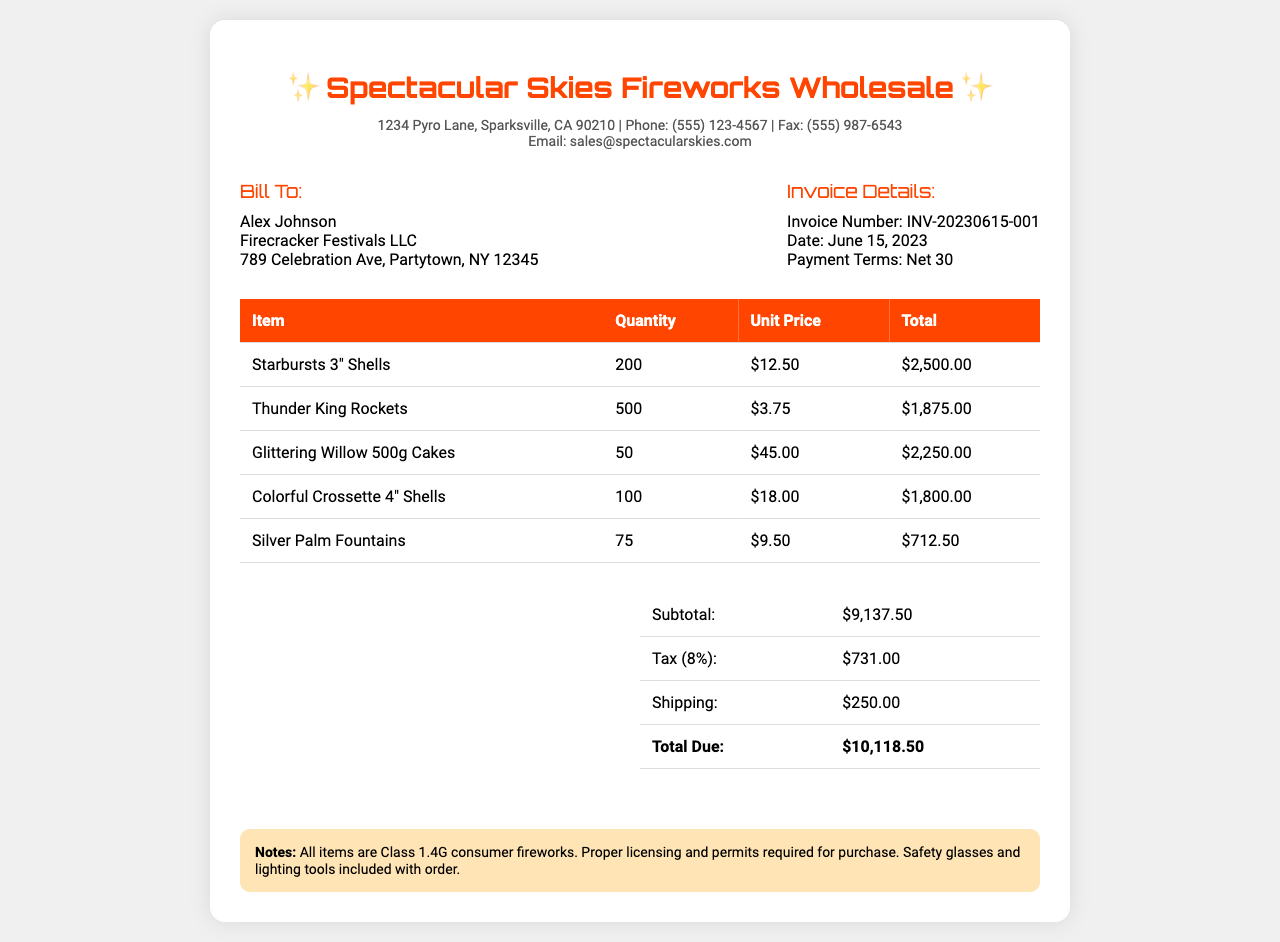What is the total due amount? The total due amount is detailed in the totals section of the document, which adds up the subtotal, tax, and shipping.
Answer: $10,118.50 Who is billed? The billing information consists of the name and company provided in the document, which identifies the recipient.
Answer: Alex Johnson When was the invoice issued? The issued date of the invoice is clearly stated in the invoice details section.
Answer: June 15, 2023 What is the payment term stated in the invoice? The payment terms are included to clarify when the payment is expected following receipt of the invoice.
Answer: Net 30 How many Thunder King Rockets were ordered? The quantity of Thunder King Rockets is specified in the detailed itemized list of the invoice.
Answer: 500 What is the subtotal of the invoice? The subtotal is explicitly shown in the totals table, summarizing the costs before tax and shipping.
Answer: $9,137.50 How much was charged for shipping? The shipping cost is provided in the totals section of the invoice, adding to the overall amount due.
Answer: $250.00 What item has the highest unit price? By reviewing the itemized list, we can identify which fireworks have the highest price per unit.
Answer: Glittering Willow 500g Cakes What percentage is the tax applied? The invoice details indicate the tax rate applied to the subtotal amount clearly.
Answer: 8% 